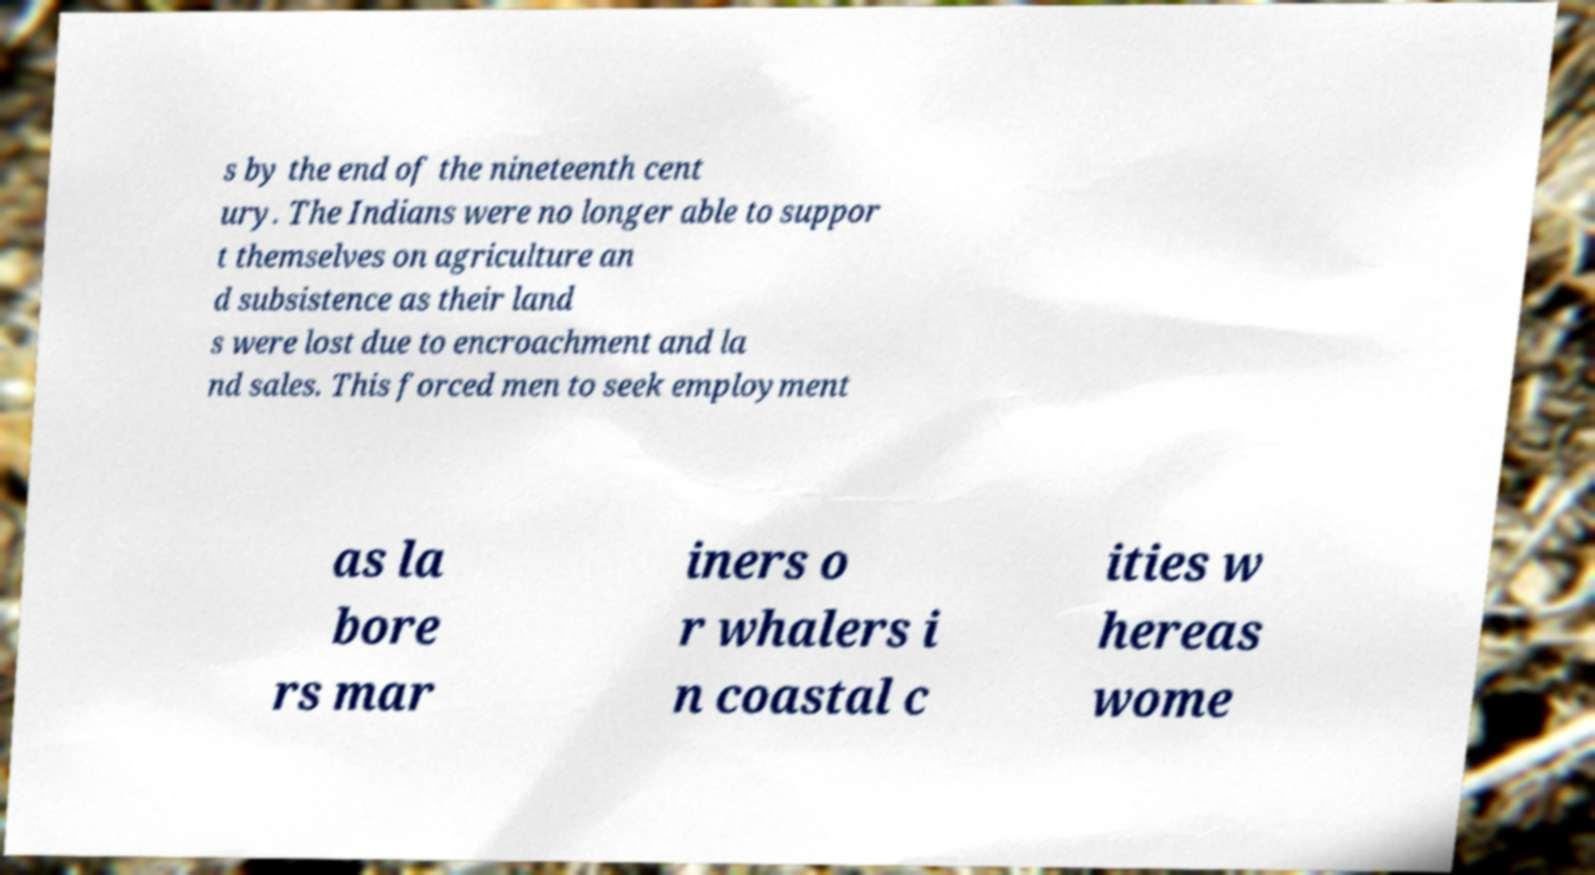Could you extract and type out the text from this image? s by the end of the nineteenth cent ury. The Indians were no longer able to suppor t themselves on agriculture an d subsistence as their land s were lost due to encroachment and la nd sales. This forced men to seek employment as la bore rs mar iners o r whalers i n coastal c ities w hereas wome 